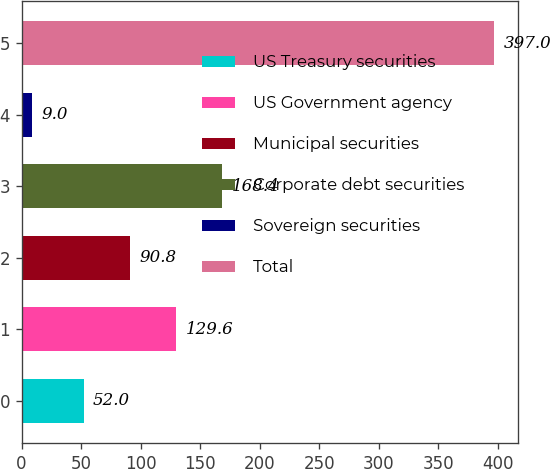<chart> <loc_0><loc_0><loc_500><loc_500><bar_chart><fcel>US Treasury securities<fcel>US Government agency<fcel>Municipal securities<fcel>Corporate debt securities<fcel>Sovereign securities<fcel>Total<nl><fcel>52<fcel>129.6<fcel>90.8<fcel>168.4<fcel>9<fcel>397<nl></chart> 